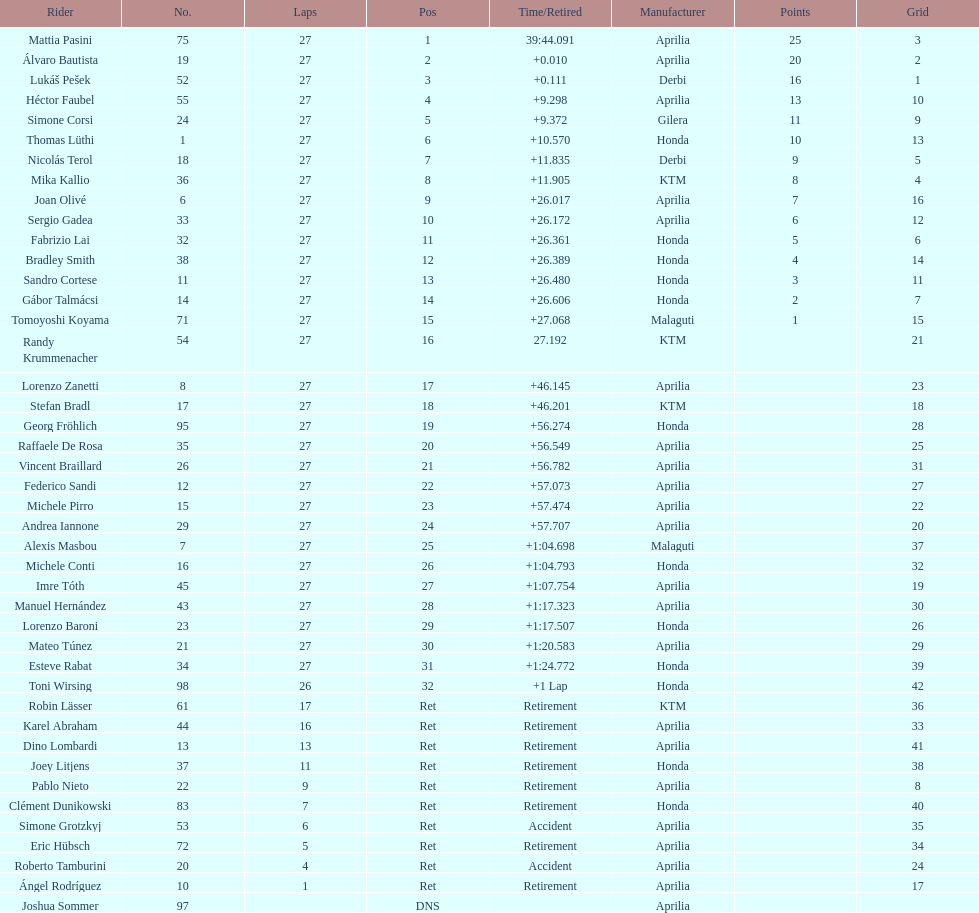Name a racer that had at least 20 points. Mattia Pasini. 